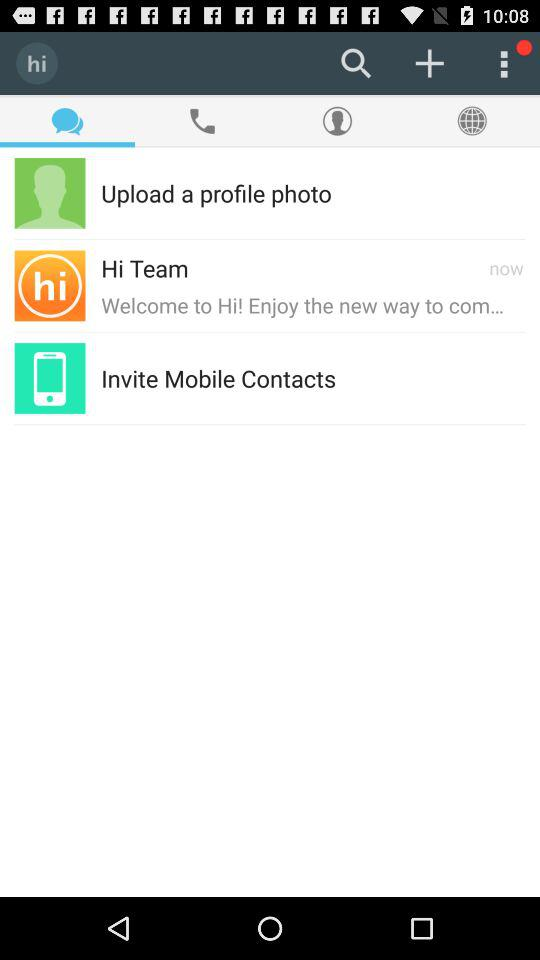Which tab is selected? The selected tab is "Chat". 